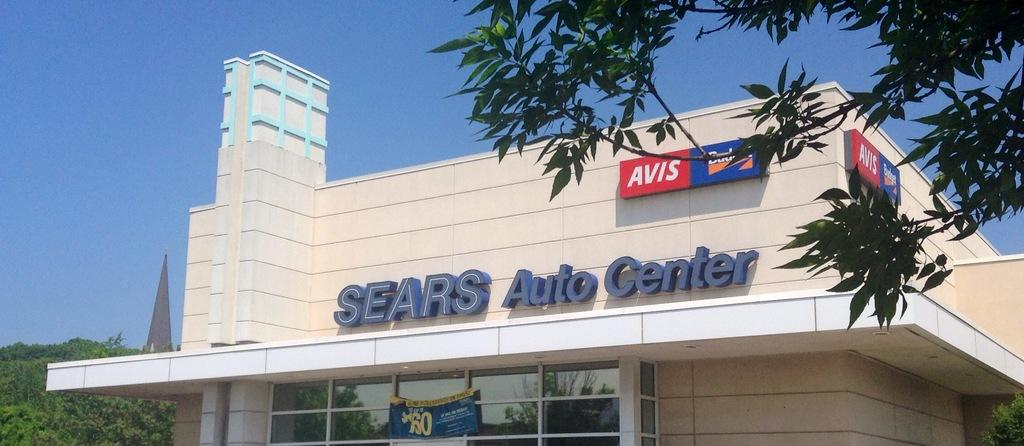Provide a one-sentence caption for the provided image. A Sears Auto Center store is on the corner of a street. 